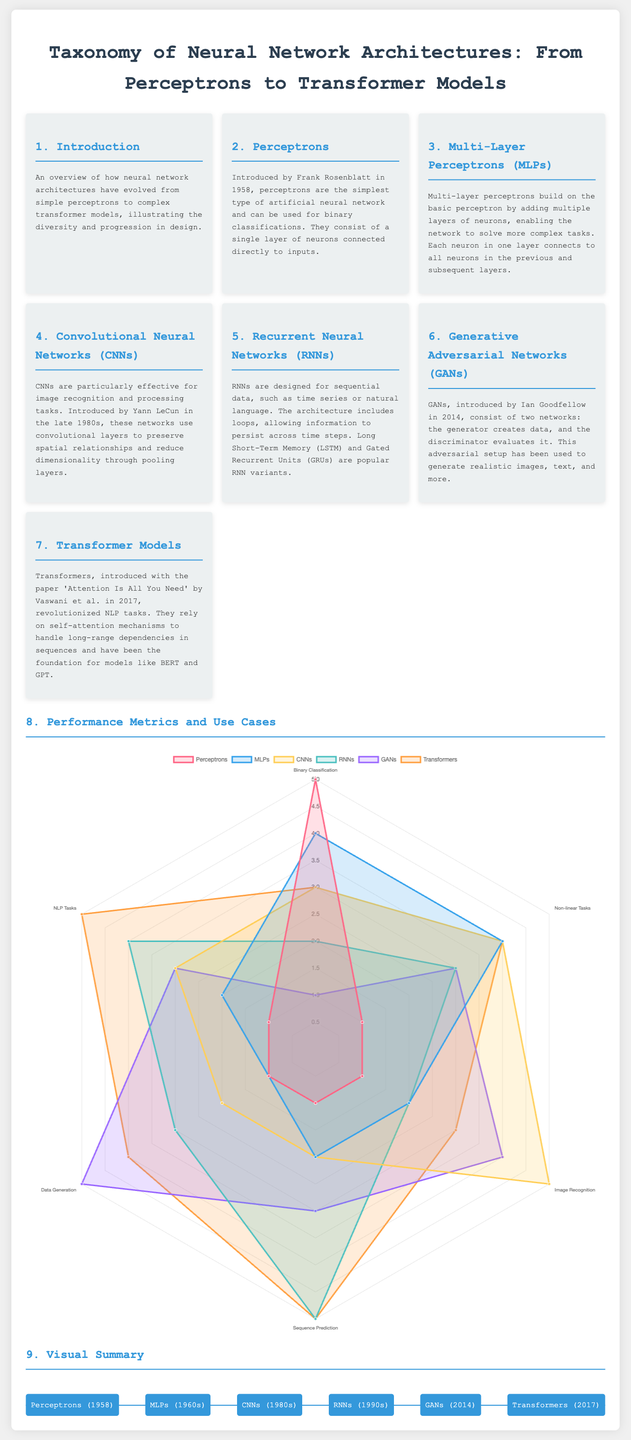What year were perceptrons introduced? Perceptrons were introduced by Frank Rosenblatt in 1958, as mentioned in the document.
Answer: 1958 What type of neural network is particularly effective for image recognition? The document states that Convolutional Neural Networks (CNNs) are particularly effective for image recognition and processing tasks.
Answer: CNNs How many main types of neural network architectures are listed? The document lists 7 main types of neural network architectures, which are detailed in the cards.
Answer: 7 What performance metric category has the highest score for Transformers? The radar chart indicates that Transformers score the highest in NLP Tasks, where the score is 5.
Answer: 5 Which neural network architecture was introduced by Ian Goodfellow? The document specifies that Generative Adversarial Networks (GANs) were introduced by Ian Goodfellow in 2014.
Answer: GANs In what decade were Multi-Layer Perceptrons popularized? The timeline in the document suggests that Multi-Layer Perceptrons became popular in the 1960s.
Answer: 1960s Which neural network is associated with the abbreviation LSTM? The document refers to Long Short-Term Memory (LSTM) as a popular variant of Recurrent Neural Networks (RNNs).
Answer: RNNs What design feature allows Recurrent Neural Networks to handle sequential data? The document explains that RNNs include loops, allowing them to persist information across time steps for sequential data.
Answer: Loops What is the main function of the discriminator in GANs? The document states that in GANs, the discriminator evaluates the data created by the generator.
Answer: Evaluates data 